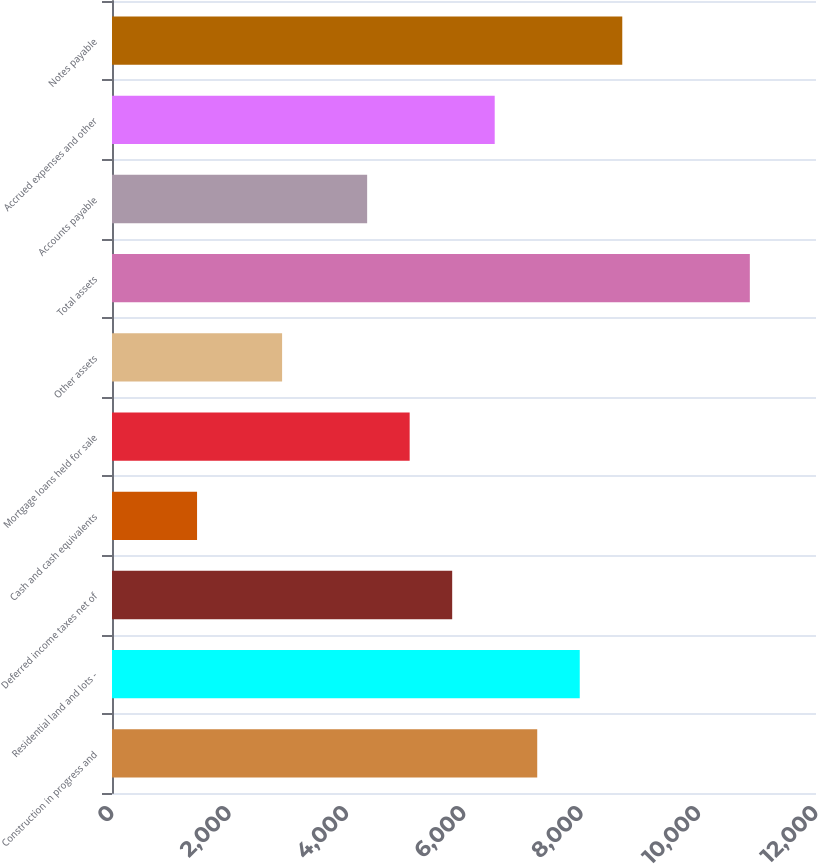Convert chart to OTSL. <chart><loc_0><loc_0><loc_500><loc_500><bar_chart><fcel>Construction in progress and<fcel>Residential land and lots -<fcel>Deferred income taxes net of<fcel>Cash and cash equivalents<fcel>Mortgage loans held for sale<fcel>Other assets<fcel>Total assets<fcel>Accounts payable<fcel>Accrued expenses and other<fcel>Notes payable<nl><fcel>7248.2<fcel>7973<fcel>5798.6<fcel>1449.8<fcel>5073.8<fcel>2899.4<fcel>10872.2<fcel>4349<fcel>6523.4<fcel>8697.8<nl></chart> 